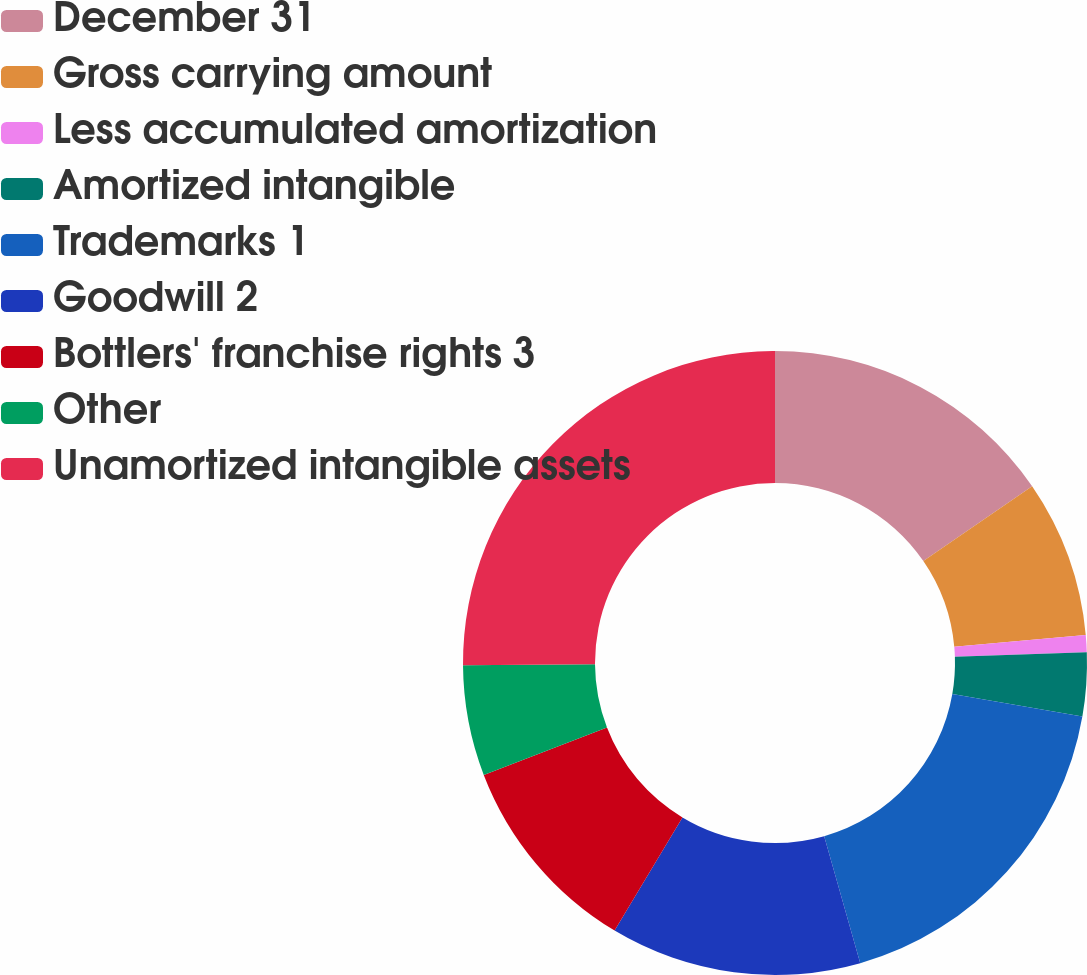Convert chart. <chart><loc_0><loc_0><loc_500><loc_500><pie_chart><fcel>December 31<fcel>Gross carrying amount<fcel>Less accumulated amortization<fcel>Amortized intangible<fcel>Trademarks 1<fcel>Goodwill 2<fcel>Bottlers' franchise rights 3<fcel>Other<fcel>Unamortized intangible assets<nl><fcel>15.42%<fcel>8.15%<fcel>0.88%<fcel>3.3%<fcel>17.85%<fcel>13.0%<fcel>10.57%<fcel>5.72%<fcel>25.12%<nl></chart> 